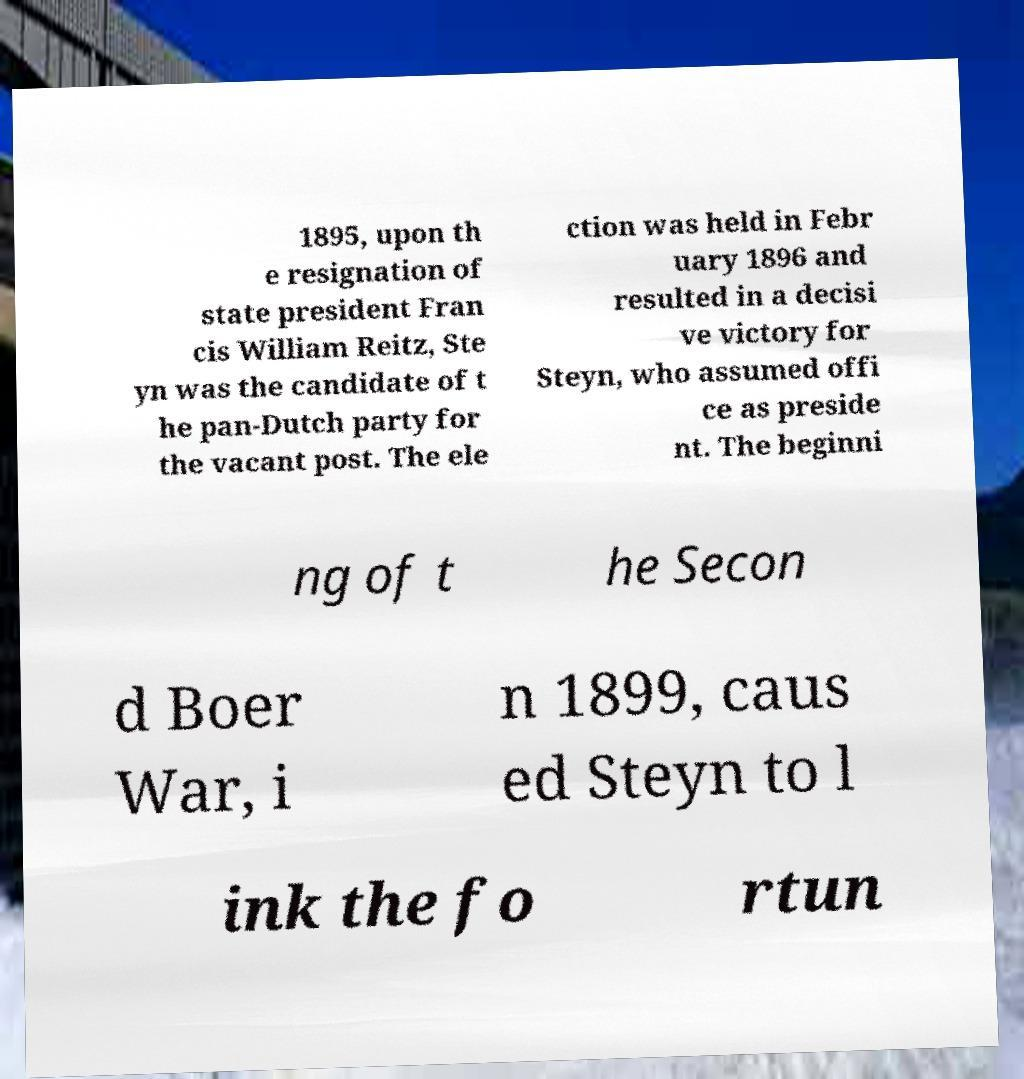Can you accurately transcribe the text from the provided image for me? 1895, upon th e resignation of state president Fran cis William Reitz, Ste yn was the candidate of t he pan-Dutch party for the vacant post. The ele ction was held in Febr uary 1896 and resulted in a decisi ve victory for Steyn, who assumed offi ce as preside nt. The beginni ng of t he Secon d Boer War, i n 1899, caus ed Steyn to l ink the fo rtun 